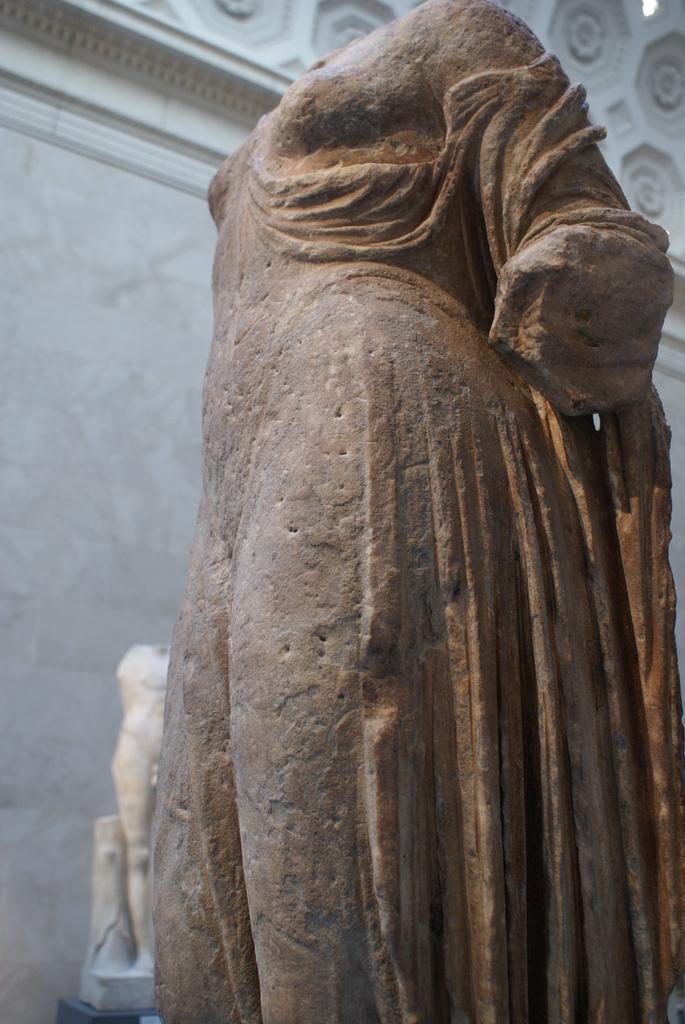How would you summarize this image in a sentence or two? In the image we can see there are stone statues and behind there are marble wall. 